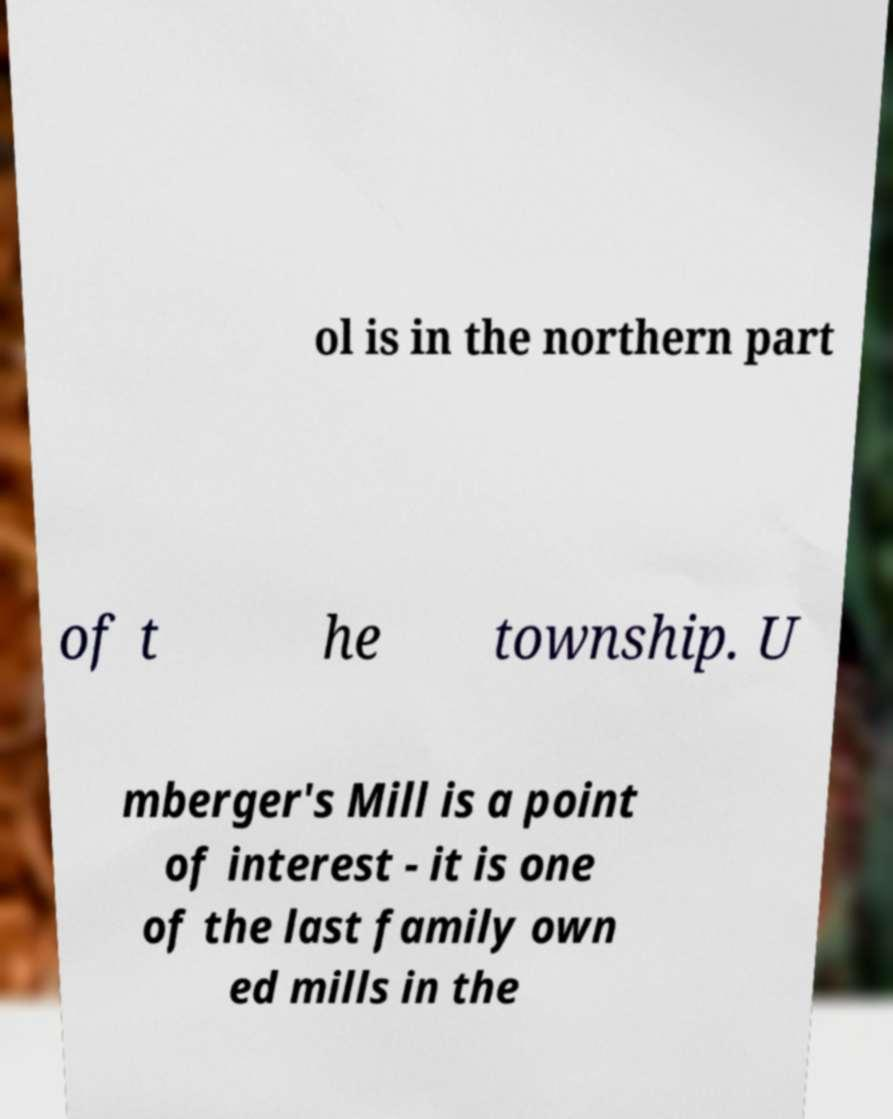Could you assist in decoding the text presented in this image and type it out clearly? ol is in the northern part of t he township. U mberger's Mill is a point of interest - it is one of the last family own ed mills in the 